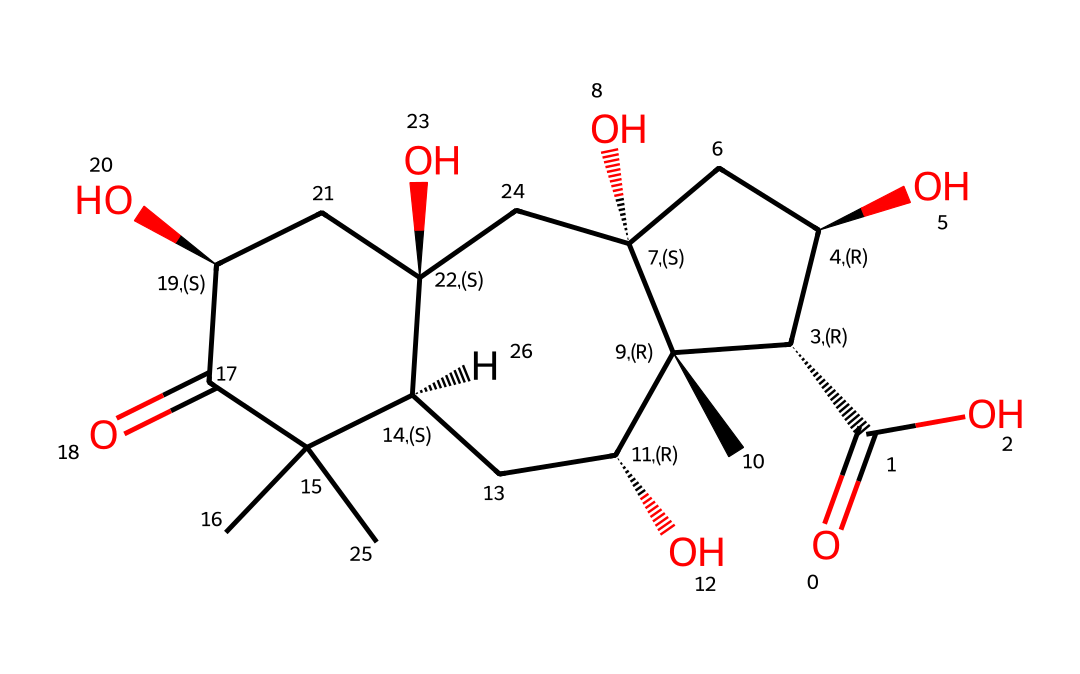what is the main functional group present in this chemical? The chemical structure shows a carboxylic acid functional group, which is indicated by the -COOH portion of the molecule. This group can be identified by the presence of a carbonyl (C=O) attached to a hydroxyl group (O-H).
Answer: carboxylic acid how many chiral centers are present in this compound? The presence of stereogenic centers can be identified by looking for carbon atoms that are attached to four different substituents. In the given SMILES, there are a total of 6 such stereogenic centers indicated by the '@' symbols.
Answer: six what is the molecular weight of this compound? To determine the molecular weight, we need to add the atomic weights of all the atoms present in the compound. By interpreting the SMILES, we find there are several carbons, oxygens, and hydrogens. The approximate molecular weight is calculated to be around 330 g/mol.
Answer: around 330 g/mol which configuration is predominant in this chiral compound? The configuration of the chiral centers can be determined from the SMILES notation, which uses '@' and '@@' to denote R and S configuration. The predominant configuration indicated by the '@' symbols in the structure suggests that the compound is predominantly in the S configuration.
Answer: S configuration how many hydroxyl groups are present? The hydroxyl groups can be identified in the structure by the -OH groups. In this SMILES representation, after counting the -OH groups in the molecule, there are a total of 4 hydroxyl groups.
Answer: four 